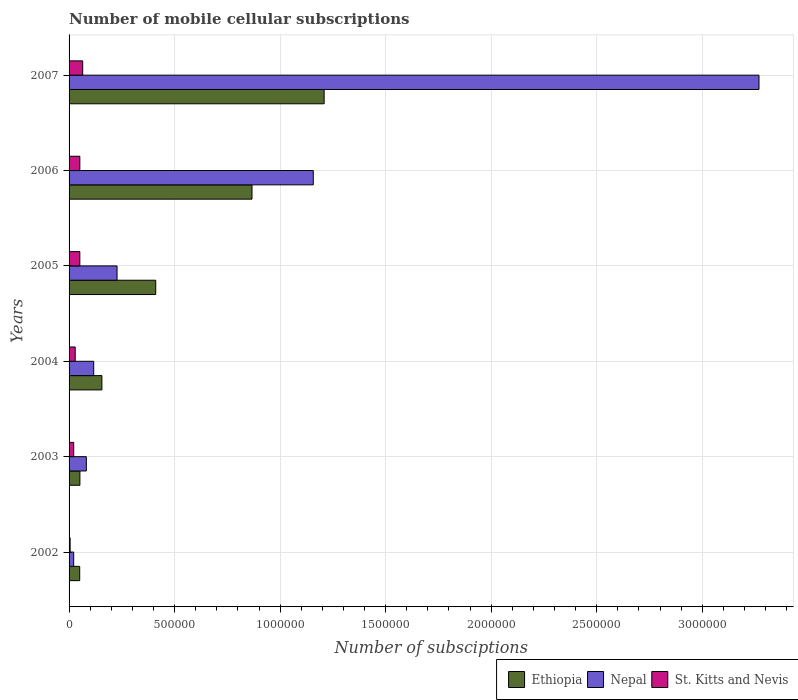How many different coloured bars are there?
Ensure brevity in your answer.  3. How many groups of bars are there?
Your response must be concise. 6. Are the number of bars per tick equal to the number of legend labels?
Your response must be concise. Yes. What is the label of the 3rd group of bars from the top?
Your answer should be very brief. 2005. What is the number of mobile cellular subscriptions in Nepal in 2002?
Ensure brevity in your answer.  2.19e+04. Across all years, what is the maximum number of mobile cellular subscriptions in St. Kitts and Nevis?
Provide a short and direct response. 6.45e+04. Across all years, what is the minimum number of mobile cellular subscriptions in St. Kitts and Nevis?
Your answer should be compact. 5000. In which year was the number of mobile cellular subscriptions in St. Kitts and Nevis maximum?
Provide a short and direct response. 2007. In which year was the number of mobile cellular subscriptions in St. Kitts and Nevis minimum?
Provide a succinct answer. 2002. What is the total number of mobile cellular subscriptions in St. Kitts and Nevis in the graph?
Give a very brief answer. 2.22e+05. What is the difference between the number of mobile cellular subscriptions in Nepal in 2003 and that in 2007?
Your answer should be very brief. -3.19e+06. What is the difference between the number of mobile cellular subscriptions in St. Kitts and Nevis in 2004 and the number of mobile cellular subscriptions in Ethiopia in 2005?
Your answer should be compact. -3.82e+05. What is the average number of mobile cellular subscriptions in St. Kitts and Nevis per year?
Provide a short and direct response. 3.71e+04. In the year 2002, what is the difference between the number of mobile cellular subscriptions in Ethiopia and number of mobile cellular subscriptions in St. Kitts and Nevis?
Provide a short and direct response. 4.54e+04. In how many years, is the number of mobile cellular subscriptions in St. Kitts and Nevis greater than 2200000 ?
Provide a succinct answer. 0. What is the ratio of the number of mobile cellular subscriptions in Ethiopia in 2003 to that in 2004?
Offer a very short reply. 0.33. Is the difference between the number of mobile cellular subscriptions in Ethiopia in 2004 and 2005 greater than the difference between the number of mobile cellular subscriptions in St. Kitts and Nevis in 2004 and 2005?
Your answer should be very brief. No. What is the difference between the highest and the second highest number of mobile cellular subscriptions in Ethiopia?
Offer a terse response. 3.42e+05. What is the difference between the highest and the lowest number of mobile cellular subscriptions in St. Kitts and Nevis?
Give a very brief answer. 5.95e+04. Is the sum of the number of mobile cellular subscriptions in Ethiopia in 2002 and 2007 greater than the maximum number of mobile cellular subscriptions in St. Kitts and Nevis across all years?
Offer a terse response. Yes. What does the 3rd bar from the top in 2003 represents?
Offer a very short reply. Ethiopia. What does the 1st bar from the bottom in 2002 represents?
Your response must be concise. Ethiopia. Is it the case that in every year, the sum of the number of mobile cellular subscriptions in Nepal and number of mobile cellular subscriptions in Ethiopia is greater than the number of mobile cellular subscriptions in St. Kitts and Nevis?
Offer a terse response. Yes. How many bars are there?
Provide a short and direct response. 18. Are all the bars in the graph horizontal?
Offer a terse response. Yes. How many years are there in the graph?
Your answer should be compact. 6. Are the values on the major ticks of X-axis written in scientific E-notation?
Your answer should be very brief. No. Does the graph contain any zero values?
Keep it short and to the point. No. Where does the legend appear in the graph?
Offer a very short reply. Bottom right. How many legend labels are there?
Ensure brevity in your answer.  3. How are the legend labels stacked?
Keep it short and to the point. Horizontal. What is the title of the graph?
Your answer should be very brief. Number of mobile cellular subscriptions. What is the label or title of the X-axis?
Offer a terse response. Number of subsciptions. What is the Number of subsciptions of Ethiopia in 2002?
Give a very brief answer. 5.04e+04. What is the Number of subsciptions in Nepal in 2002?
Keep it short and to the point. 2.19e+04. What is the Number of subsciptions in St. Kitts and Nevis in 2002?
Give a very brief answer. 5000. What is the Number of subsciptions of Ethiopia in 2003?
Offer a very short reply. 5.13e+04. What is the Number of subsciptions of Nepal in 2003?
Your response must be concise. 8.19e+04. What is the Number of subsciptions in St. Kitts and Nevis in 2003?
Ensure brevity in your answer.  2.20e+04. What is the Number of subsciptions of Ethiopia in 2004?
Offer a very short reply. 1.56e+05. What is the Number of subsciptions in Nepal in 2004?
Give a very brief answer. 1.17e+05. What is the Number of subsciptions of St. Kitts and Nevis in 2004?
Your response must be concise. 2.90e+04. What is the Number of subsciptions of Ethiopia in 2005?
Provide a short and direct response. 4.11e+05. What is the Number of subsciptions of Nepal in 2005?
Your answer should be compact. 2.27e+05. What is the Number of subsciptions of St. Kitts and Nevis in 2005?
Provide a short and direct response. 5.10e+04. What is the Number of subsciptions of Ethiopia in 2006?
Your answer should be very brief. 8.67e+05. What is the Number of subsciptions in Nepal in 2006?
Provide a short and direct response. 1.16e+06. What is the Number of subsciptions in St. Kitts and Nevis in 2006?
Your response must be concise. 5.10e+04. What is the Number of subsciptions of Ethiopia in 2007?
Give a very brief answer. 1.21e+06. What is the Number of subsciptions of Nepal in 2007?
Your answer should be compact. 3.27e+06. What is the Number of subsciptions in St. Kitts and Nevis in 2007?
Provide a succinct answer. 6.45e+04. Across all years, what is the maximum Number of subsciptions in Ethiopia?
Provide a succinct answer. 1.21e+06. Across all years, what is the maximum Number of subsciptions in Nepal?
Offer a very short reply. 3.27e+06. Across all years, what is the maximum Number of subsciptions of St. Kitts and Nevis?
Your response must be concise. 6.45e+04. Across all years, what is the minimum Number of subsciptions of Ethiopia?
Offer a very short reply. 5.04e+04. Across all years, what is the minimum Number of subsciptions of Nepal?
Offer a very short reply. 2.19e+04. What is the total Number of subsciptions of Ethiopia in the graph?
Keep it short and to the point. 2.74e+06. What is the total Number of subsciptions of Nepal in the graph?
Offer a terse response. 4.87e+06. What is the total Number of subsciptions in St. Kitts and Nevis in the graph?
Your answer should be compact. 2.22e+05. What is the difference between the Number of subsciptions of Ethiopia in 2002 and that in 2003?
Keep it short and to the point. -955. What is the difference between the Number of subsciptions of Nepal in 2002 and that in 2003?
Ensure brevity in your answer.  -6.00e+04. What is the difference between the Number of subsciptions of St. Kitts and Nevis in 2002 and that in 2003?
Your response must be concise. -1.70e+04. What is the difference between the Number of subsciptions of Ethiopia in 2002 and that in 2004?
Offer a terse response. -1.05e+05. What is the difference between the Number of subsciptions in Nepal in 2002 and that in 2004?
Give a very brief answer. -9.49e+04. What is the difference between the Number of subsciptions of St. Kitts and Nevis in 2002 and that in 2004?
Provide a succinct answer. -2.40e+04. What is the difference between the Number of subsciptions in Ethiopia in 2002 and that in 2005?
Offer a terse response. -3.60e+05. What is the difference between the Number of subsciptions in Nepal in 2002 and that in 2005?
Provide a succinct answer. -2.05e+05. What is the difference between the Number of subsciptions in St. Kitts and Nevis in 2002 and that in 2005?
Make the answer very short. -4.60e+04. What is the difference between the Number of subsciptions in Ethiopia in 2002 and that in 2006?
Give a very brief answer. -8.16e+05. What is the difference between the Number of subsciptions of Nepal in 2002 and that in 2006?
Give a very brief answer. -1.14e+06. What is the difference between the Number of subsciptions in St. Kitts and Nevis in 2002 and that in 2006?
Provide a succinct answer. -4.60e+04. What is the difference between the Number of subsciptions in Ethiopia in 2002 and that in 2007?
Provide a succinct answer. -1.16e+06. What is the difference between the Number of subsciptions of Nepal in 2002 and that in 2007?
Give a very brief answer. -3.25e+06. What is the difference between the Number of subsciptions in St. Kitts and Nevis in 2002 and that in 2007?
Ensure brevity in your answer.  -5.95e+04. What is the difference between the Number of subsciptions of Ethiopia in 2003 and that in 2004?
Make the answer very short. -1.04e+05. What is the difference between the Number of subsciptions of Nepal in 2003 and that in 2004?
Your answer should be very brief. -3.49e+04. What is the difference between the Number of subsciptions in St. Kitts and Nevis in 2003 and that in 2004?
Make the answer very short. -7000. What is the difference between the Number of subsciptions of Ethiopia in 2003 and that in 2005?
Provide a short and direct response. -3.59e+05. What is the difference between the Number of subsciptions in Nepal in 2003 and that in 2005?
Provide a short and direct response. -1.45e+05. What is the difference between the Number of subsciptions of St. Kitts and Nevis in 2003 and that in 2005?
Your response must be concise. -2.90e+04. What is the difference between the Number of subsciptions of Ethiopia in 2003 and that in 2006?
Your answer should be compact. -8.15e+05. What is the difference between the Number of subsciptions in Nepal in 2003 and that in 2006?
Keep it short and to the point. -1.08e+06. What is the difference between the Number of subsciptions in St. Kitts and Nevis in 2003 and that in 2006?
Ensure brevity in your answer.  -2.90e+04. What is the difference between the Number of subsciptions in Ethiopia in 2003 and that in 2007?
Offer a terse response. -1.16e+06. What is the difference between the Number of subsciptions in Nepal in 2003 and that in 2007?
Your answer should be very brief. -3.19e+06. What is the difference between the Number of subsciptions in St. Kitts and Nevis in 2003 and that in 2007?
Make the answer very short. -4.25e+04. What is the difference between the Number of subsciptions in Ethiopia in 2004 and that in 2005?
Keep it short and to the point. -2.55e+05. What is the difference between the Number of subsciptions of Nepal in 2004 and that in 2005?
Your answer should be compact. -1.11e+05. What is the difference between the Number of subsciptions in St. Kitts and Nevis in 2004 and that in 2005?
Give a very brief answer. -2.20e+04. What is the difference between the Number of subsciptions in Ethiopia in 2004 and that in 2006?
Provide a succinct answer. -7.11e+05. What is the difference between the Number of subsciptions of Nepal in 2004 and that in 2006?
Make the answer very short. -1.04e+06. What is the difference between the Number of subsciptions of St. Kitts and Nevis in 2004 and that in 2006?
Provide a succinct answer. -2.20e+04. What is the difference between the Number of subsciptions of Ethiopia in 2004 and that in 2007?
Provide a succinct answer. -1.05e+06. What is the difference between the Number of subsciptions of Nepal in 2004 and that in 2007?
Ensure brevity in your answer.  -3.15e+06. What is the difference between the Number of subsciptions in St. Kitts and Nevis in 2004 and that in 2007?
Make the answer very short. -3.55e+04. What is the difference between the Number of subsciptions in Ethiopia in 2005 and that in 2006?
Keep it short and to the point. -4.56e+05. What is the difference between the Number of subsciptions in Nepal in 2005 and that in 2006?
Give a very brief answer. -9.30e+05. What is the difference between the Number of subsciptions in Ethiopia in 2005 and that in 2007?
Keep it short and to the point. -7.98e+05. What is the difference between the Number of subsciptions of Nepal in 2005 and that in 2007?
Your response must be concise. -3.04e+06. What is the difference between the Number of subsciptions of St. Kitts and Nevis in 2005 and that in 2007?
Give a very brief answer. -1.35e+04. What is the difference between the Number of subsciptions of Ethiopia in 2006 and that in 2007?
Offer a very short reply. -3.42e+05. What is the difference between the Number of subsciptions in Nepal in 2006 and that in 2007?
Your answer should be very brief. -2.11e+06. What is the difference between the Number of subsciptions in St. Kitts and Nevis in 2006 and that in 2007?
Offer a terse response. -1.35e+04. What is the difference between the Number of subsciptions in Ethiopia in 2002 and the Number of subsciptions in Nepal in 2003?
Offer a terse response. -3.15e+04. What is the difference between the Number of subsciptions in Ethiopia in 2002 and the Number of subsciptions in St. Kitts and Nevis in 2003?
Provide a short and direct response. 2.84e+04. What is the difference between the Number of subsciptions in Nepal in 2002 and the Number of subsciptions in St. Kitts and Nevis in 2003?
Your answer should be very brief. -119. What is the difference between the Number of subsciptions in Ethiopia in 2002 and the Number of subsciptions in Nepal in 2004?
Provide a succinct answer. -6.64e+04. What is the difference between the Number of subsciptions of Ethiopia in 2002 and the Number of subsciptions of St. Kitts and Nevis in 2004?
Ensure brevity in your answer.  2.14e+04. What is the difference between the Number of subsciptions of Nepal in 2002 and the Number of subsciptions of St. Kitts and Nevis in 2004?
Provide a succinct answer. -7119. What is the difference between the Number of subsciptions of Ethiopia in 2002 and the Number of subsciptions of Nepal in 2005?
Keep it short and to the point. -1.77e+05. What is the difference between the Number of subsciptions of Ethiopia in 2002 and the Number of subsciptions of St. Kitts and Nevis in 2005?
Your answer should be very brief. -631. What is the difference between the Number of subsciptions of Nepal in 2002 and the Number of subsciptions of St. Kitts and Nevis in 2005?
Give a very brief answer. -2.91e+04. What is the difference between the Number of subsciptions in Ethiopia in 2002 and the Number of subsciptions in Nepal in 2006?
Keep it short and to the point. -1.11e+06. What is the difference between the Number of subsciptions in Ethiopia in 2002 and the Number of subsciptions in St. Kitts and Nevis in 2006?
Your answer should be compact. -631. What is the difference between the Number of subsciptions of Nepal in 2002 and the Number of subsciptions of St. Kitts and Nevis in 2006?
Make the answer very short. -2.91e+04. What is the difference between the Number of subsciptions of Ethiopia in 2002 and the Number of subsciptions of Nepal in 2007?
Offer a very short reply. -3.22e+06. What is the difference between the Number of subsciptions in Ethiopia in 2002 and the Number of subsciptions in St. Kitts and Nevis in 2007?
Ensure brevity in your answer.  -1.41e+04. What is the difference between the Number of subsciptions of Nepal in 2002 and the Number of subsciptions of St. Kitts and Nevis in 2007?
Your response must be concise. -4.26e+04. What is the difference between the Number of subsciptions of Ethiopia in 2003 and the Number of subsciptions of Nepal in 2004?
Offer a terse response. -6.55e+04. What is the difference between the Number of subsciptions in Ethiopia in 2003 and the Number of subsciptions in St. Kitts and Nevis in 2004?
Ensure brevity in your answer.  2.23e+04. What is the difference between the Number of subsciptions in Nepal in 2003 and the Number of subsciptions in St. Kitts and Nevis in 2004?
Keep it short and to the point. 5.29e+04. What is the difference between the Number of subsciptions in Ethiopia in 2003 and the Number of subsciptions in Nepal in 2005?
Ensure brevity in your answer.  -1.76e+05. What is the difference between the Number of subsciptions in Ethiopia in 2003 and the Number of subsciptions in St. Kitts and Nevis in 2005?
Offer a terse response. 324. What is the difference between the Number of subsciptions of Nepal in 2003 and the Number of subsciptions of St. Kitts and Nevis in 2005?
Ensure brevity in your answer.  3.09e+04. What is the difference between the Number of subsciptions of Ethiopia in 2003 and the Number of subsciptions of Nepal in 2006?
Make the answer very short. -1.11e+06. What is the difference between the Number of subsciptions in Ethiopia in 2003 and the Number of subsciptions in St. Kitts and Nevis in 2006?
Provide a short and direct response. 324. What is the difference between the Number of subsciptions of Nepal in 2003 and the Number of subsciptions of St. Kitts and Nevis in 2006?
Your answer should be very brief. 3.09e+04. What is the difference between the Number of subsciptions in Ethiopia in 2003 and the Number of subsciptions in Nepal in 2007?
Your response must be concise. -3.22e+06. What is the difference between the Number of subsciptions of Ethiopia in 2003 and the Number of subsciptions of St. Kitts and Nevis in 2007?
Your answer should be compact. -1.32e+04. What is the difference between the Number of subsciptions of Nepal in 2003 and the Number of subsciptions of St. Kitts and Nevis in 2007?
Your response must be concise. 1.74e+04. What is the difference between the Number of subsciptions in Ethiopia in 2004 and the Number of subsciptions in Nepal in 2005?
Offer a very short reply. -7.18e+04. What is the difference between the Number of subsciptions of Ethiopia in 2004 and the Number of subsciptions of St. Kitts and Nevis in 2005?
Provide a short and direct response. 1.05e+05. What is the difference between the Number of subsciptions in Nepal in 2004 and the Number of subsciptions in St. Kitts and Nevis in 2005?
Give a very brief answer. 6.58e+04. What is the difference between the Number of subsciptions in Ethiopia in 2004 and the Number of subsciptions in Nepal in 2006?
Ensure brevity in your answer.  -1.00e+06. What is the difference between the Number of subsciptions of Ethiopia in 2004 and the Number of subsciptions of St. Kitts and Nevis in 2006?
Give a very brief answer. 1.05e+05. What is the difference between the Number of subsciptions of Nepal in 2004 and the Number of subsciptions of St. Kitts and Nevis in 2006?
Your response must be concise. 6.58e+04. What is the difference between the Number of subsciptions of Ethiopia in 2004 and the Number of subsciptions of Nepal in 2007?
Your answer should be very brief. -3.11e+06. What is the difference between the Number of subsciptions in Ethiopia in 2004 and the Number of subsciptions in St. Kitts and Nevis in 2007?
Keep it short and to the point. 9.10e+04. What is the difference between the Number of subsciptions of Nepal in 2004 and the Number of subsciptions of St. Kitts and Nevis in 2007?
Provide a succinct answer. 5.23e+04. What is the difference between the Number of subsciptions of Ethiopia in 2005 and the Number of subsciptions of Nepal in 2006?
Provide a succinct answer. -7.46e+05. What is the difference between the Number of subsciptions of Ethiopia in 2005 and the Number of subsciptions of St. Kitts and Nevis in 2006?
Your response must be concise. 3.60e+05. What is the difference between the Number of subsciptions in Nepal in 2005 and the Number of subsciptions in St. Kitts and Nevis in 2006?
Provide a succinct answer. 1.76e+05. What is the difference between the Number of subsciptions in Ethiopia in 2005 and the Number of subsciptions in Nepal in 2007?
Make the answer very short. -2.86e+06. What is the difference between the Number of subsciptions of Ethiopia in 2005 and the Number of subsciptions of St. Kitts and Nevis in 2007?
Your answer should be very brief. 3.46e+05. What is the difference between the Number of subsciptions in Nepal in 2005 and the Number of subsciptions in St. Kitts and Nevis in 2007?
Provide a succinct answer. 1.63e+05. What is the difference between the Number of subsciptions in Ethiopia in 2006 and the Number of subsciptions in Nepal in 2007?
Keep it short and to the point. -2.40e+06. What is the difference between the Number of subsciptions in Ethiopia in 2006 and the Number of subsciptions in St. Kitts and Nevis in 2007?
Provide a short and direct response. 8.02e+05. What is the difference between the Number of subsciptions in Nepal in 2006 and the Number of subsciptions in St. Kitts and Nevis in 2007?
Keep it short and to the point. 1.09e+06. What is the average Number of subsciptions in Ethiopia per year?
Provide a succinct answer. 4.57e+05. What is the average Number of subsciptions in Nepal per year?
Provide a succinct answer. 8.12e+05. What is the average Number of subsciptions of St. Kitts and Nevis per year?
Your response must be concise. 3.71e+04. In the year 2002, what is the difference between the Number of subsciptions of Ethiopia and Number of subsciptions of Nepal?
Make the answer very short. 2.85e+04. In the year 2002, what is the difference between the Number of subsciptions in Ethiopia and Number of subsciptions in St. Kitts and Nevis?
Give a very brief answer. 4.54e+04. In the year 2002, what is the difference between the Number of subsciptions in Nepal and Number of subsciptions in St. Kitts and Nevis?
Keep it short and to the point. 1.69e+04. In the year 2003, what is the difference between the Number of subsciptions in Ethiopia and Number of subsciptions in Nepal?
Your answer should be very brief. -3.05e+04. In the year 2003, what is the difference between the Number of subsciptions of Ethiopia and Number of subsciptions of St. Kitts and Nevis?
Give a very brief answer. 2.93e+04. In the year 2003, what is the difference between the Number of subsciptions in Nepal and Number of subsciptions in St. Kitts and Nevis?
Keep it short and to the point. 5.99e+04. In the year 2004, what is the difference between the Number of subsciptions in Ethiopia and Number of subsciptions in Nepal?
Give a very brief answer. 3.88e+04. In the year 2004, what is the difference between the Number of subsciptions of Ethiopia and Number of subsciptions of St. Kitts and Nevis?
Offer a very short reply. 1.27e+05. In the year 2004, what is the difference between the Number of subsciptions of Nepal and Number of subsciptions of St. Kitts and Nevis?
Your response must be concise. 8.78e+04. In the year 2005, what is the difference between the Number of subsciptions in Ethiopia and Number of subsciptions in Nepal?
Provide a short and direct response. 1.83e+05. In the year 2005, what is the difference between the Number of subsciptions of Ethiopia and Number of subsciptions of St. Kitts and Nevis?
Your answer should be very brief. 3.60e+05. In the year 2005, what is the difference between the Number of subsciptions in Nepal and Number of subsciptions in St. Kitts and Nevis?
Your answer should be compact. 1.76e+05. In the year 2006, what is the difference between the Number of subsciptions of Ethiopia and Number of subsciptions of Nepal?
Give a very brief answer. -2.90e+05. In the year 2006, what is the difference between the Number of subsciptions in Ethiopia and Number of subsciptions in St. Kitts and Nevis?
Give a very brief answer. 8.16e+05. In the year 2006, what is the difference between the Number of subsciptions of Nepal and Number of subsciptions of St. Kitts and Nevis?
Your answer should be very brief. 1.11e+06. In the year 2007, what is the difference between the Number of subsciptions of Ethiopia and Number of subsciptions of Nepal?
Offer a terse response. -2.06e+06. In the year 2007, what is the difference between the Number of subsciptions in Ethiopia and Number of subsciptions in St. Kitts and Nevis?
Offer a very short reply. 1.14e+06. In the year 2007, what is the difference between the Number of subsciptions in Nepal and Number of subsciptions in St. Kitts and Nevis?
Provide a succinct answer. 3.20e+06. What is the ratio of the Number of subsciptions of Ethiopia in 2002 to that in 2003?
Provide a succinct answer. 0.98. What is the ratio of the Number of subsciptions of Nepal in 2002 to that in 2003?
Your response must be concise. 0.27. What is the ratio of the Number of subsciptions in St. Kitts and Nevis in 2002 to that in 2003?
Your response must be concise. 0.23. What is the ratio of the Number of subsciptions in Ethiopia in 2002 to that in 2004?
Give a very brief answer. 0.32. What is the ratio of the Number of subsciptions of Nepal in 2002 to that in 2004?
Ensure brevity in your answer.  0.19. What is the ratio of the Number of subsciptions of St. Kitts and Nevis in 2002 to that in 2004?
Your answer should be very brief. 0.17. What is the ratio of the Number of subsciptions of Ethiopia in 2002 to that in 2005?
Offer a very short reply. 0.12. What is the ratio of the Number of subsciptions of Nepal in 2002 to that in 2005?
Provide a short and direct response. 0.1. What is the ratio of the Number of subsciptions in St. Kitts and Nevis in 2002 to that in 2005?
Offer a very short reply. 0.1. What is the ratio of the Number of subsciptions of Ethiopia in 2002 to that in 2006?
Your answer should be compact. 0.06. What is the ratio of the Number of subsciptions in Nepal in 2002 to that in 2006?
Offer a terse response. 0.02. What is the ratio of the Number of subsciptions of St. Kitts and Nevis in 2002 to that in 2006?
Offer a terse response. 0.1. What is the ratio of the Number of subsciptions of Ethiopia in 2002 to that in 2007?
Ensure brevity in your answer.  0.04. What is the ratio of the Number of subsciptions of Nepal in 2002 to that in 2007?
Ensure brevity in your answer.  0.01. What is the ratio of the Number of subsciptions in St. Kitts and Nevis in 2002 to that in 2007?
Your response must be concise. 0.08. What is the ratio of the Number of subsciptions of Ethiopia in 2003 to that in 2004?
Give a very brief answer. 0.33. What is the ratio of the Number of subsciptions of Nepal in 2003 to that in 2004?
Make the answer very short. 0.7. What is the ratio of the Number of subsciptions of St. Kitts and Nevis in 2003 to that in 2004?
Offer a very short reply. 0.76. What is the ratio of the Number of subsciptions in Nepal in 2003 to that in 2005?
Keep it short and to the point. 0.36. What is the ratio of the Number of subsciptions in St. Kitts and Nevis in 2003 to that in 2005?
Your answer should be compact. 0.43. What is the ratio of the Number of subsciptions of Ethiopia in 2003 to that in 2006?
Offer a terse response. 0.06. What is the ratio of the Number of subsciptions of Nepal in 2003 to that in 2006?
Provide a short and direct response. 0.07. What is the ratio of the Number of subsciptions in St. Kitts and Nevis in 2003 to that in 2006?
Ensure brevity in your answer.  0.43. What is the ratio of the Number of subsciptions in Ethiopia in 2003 to that in 2007?
Your answer should be compact. 0.04. What is the ratio of the Number of subsciptions in Nepal in 2003 to that in 2007?
Offer a terse response. 0.03. What is the ratio of the Number of subsciptions of St. Kitts and Nevis in 2003 to that in 2007?
Your response must be concise. 0.34. What is the ratio of the Number of subsciptions in Ethiopia in 2004 to that in 2005?
Offer a very short reply. 0.38. What is the ratio of the Number of subsciptions in Nepal in 2004 to that in 2005?
Make the answer very short. 0.51. What is the ratio of the Number of subsciptions in St. Kitts and Nevis in 2004 to that in 2005?
Your answer should be very brief. 0.57. What is the ratio of the Number of subsciptions in Ethiopia in 2004 to that in 2006?
Your answer should be compact. 0.18. What is the ratio of the Number of subsciptions of Nepal in 2004 to that in 2006?
Offer a very short reply. 0.1. What is the ratio of the Number of subsciptions in St. Kitts and Nevis in 2004 to that in 2006?
Your response must be concise. 0.57. What is the ratio of the Number of subsciptions of Ethiopia in 2004 to that in 2007?
Ensure brevity in your answer.  0.13. What is the ratio of the Number of subsciptions in Nepal in 2004 to that in 2007?
Your answer should be very brief. 0.04. What is the ratio of the Number of subsciptions in St. Kitts and Nevis in 2004 to that in 2007?
Keep it short and to the point. 0.45. What is the ratio of the Number of subsciptions in Ethiopia in 2005 to that in 2006?
Keep it short and to the point. 0.47. What is the ratio of the Number of subsciptions of Nepal in 2005 to that in 2006?
Make the answer very short. 0.2. What is the ratio of the Number of subsciptions in Ethiopia in 2005 to that in 2007?
Give a very brief answer. 0.34. What is the ratio of the Number of subsciptions of Nepal in 2005 to that in 2007?
Provide a succinct answer. 0.07. What is the ratio of the Number of subsciptions in St. Kitts and Nevis in 2005 to that in 2007?
Your response must be concise. 0.79. What is the ratio of the Number of subsciptions in Ethiopia in 2006 to that in 2007?
Provide a succinct answer. 0.72. What is the ratio of the Number of subsciptions in Nepal in 2006 to that in 2007?
Keep it short and to the point. 0.35. What is the ratio of the Number of subsciptions in St. Kitts and Nevis in 2006 to that in 2007?
Make the answer very short. 0.79. What is the difference between the highest and the second highest Number of subsciptions of Ethiopia?
Your response must be concise. 3.42e+05. What is the difference between the highest and the second highest Number of subsciptions of Nepal?
Ensure brevity in your answer.  2.11e+06. What is the difference between the highest and the second highest Number of subsciptions of St. Kitts and Nevis?
Provide a short and direct response. 1.35e+04. What is the difference between the highest and the lowest Number of subsciptions of Ethiopia?
Make the answer very short. 1.16e+06. What is the difference between the highest and the lowest Number of subsciptions in Nepal?
Your response must be concise. 3.25e+06. What is the difference between the highest and the lowest Number of subsciptions of St. Kitts and Nevis?
Your answer should be very brief. 5.95e+04. 